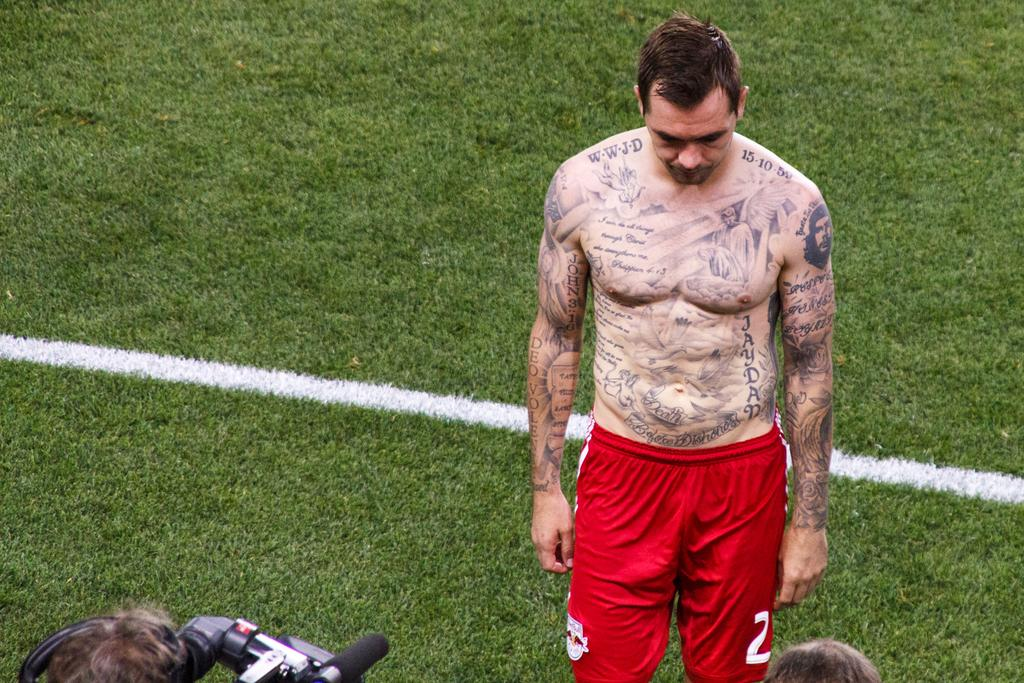What is the primary feature of the land in the image? The land is covered with grass. Can you describe the person in the image? The person has tattoos on their body and is holding a camera. What is attached to the camera? The camera has a mic attached to it. What crime is the person committing in the image? There is no indication of a crime being committed in the image. What journey is the person embarking on with the camera and mic? The image does not provide information about a journey or destination. 